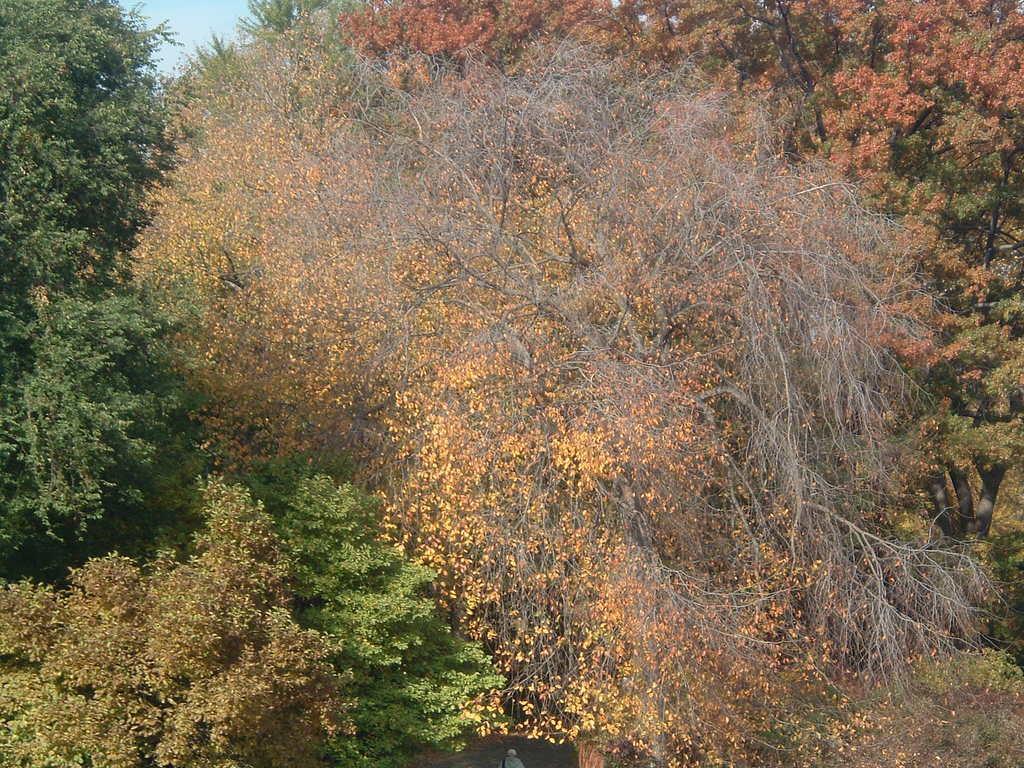Could you give a brief overview of what you see in this image? In this picture we can observe trees. There are yellow color and green color trees. We can observe some dried trees too. In the background there is a sky. 